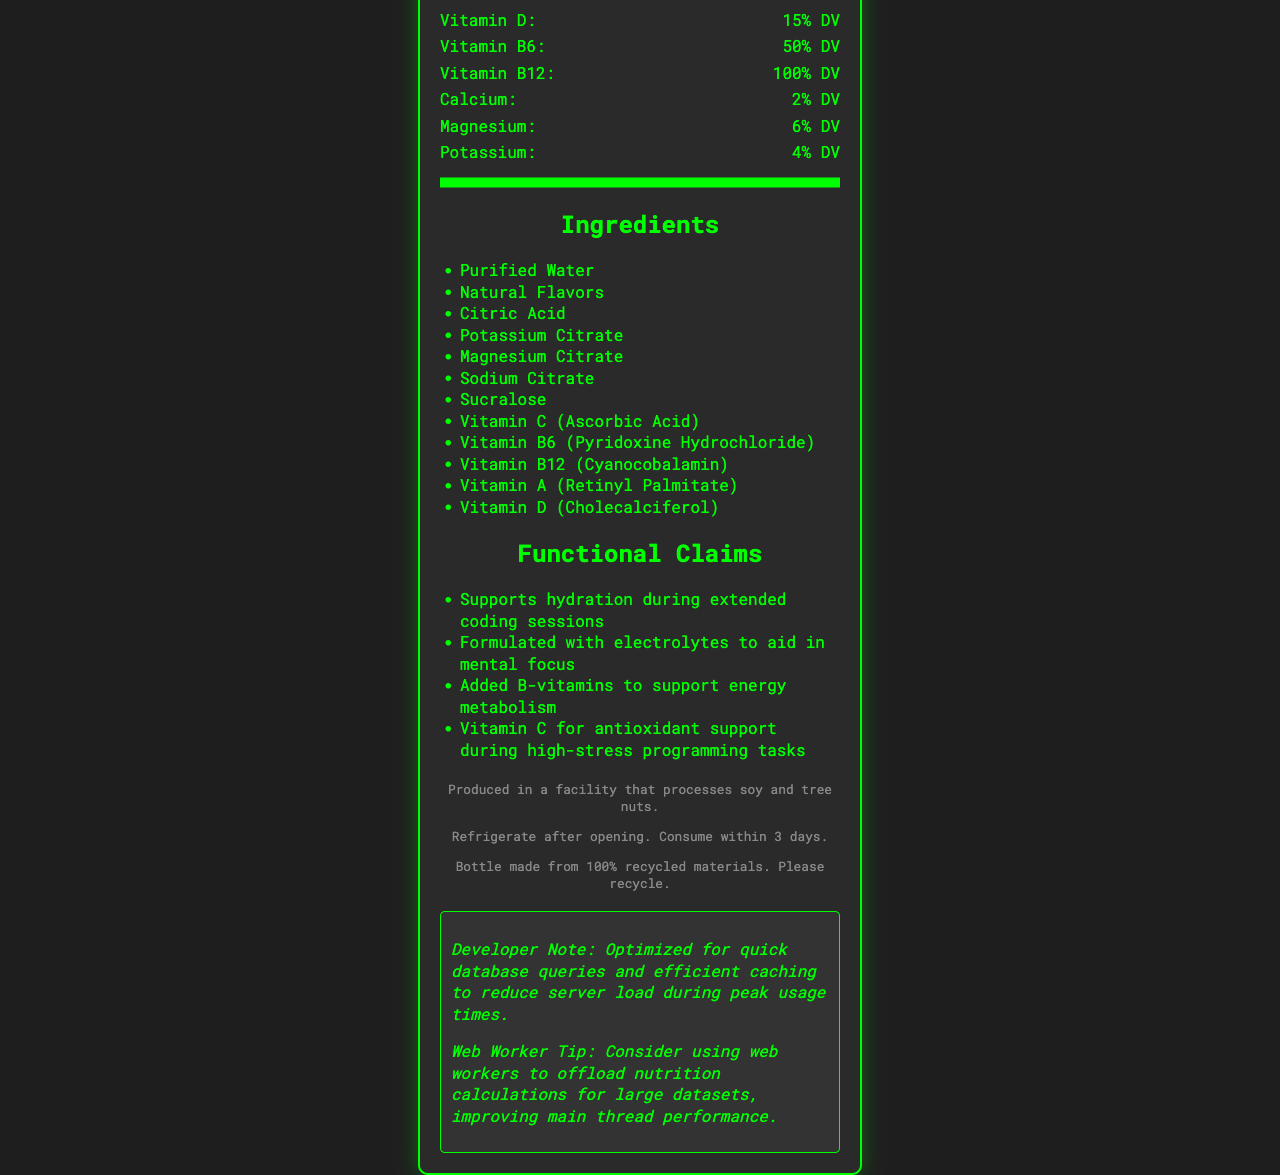what is the serving size? The serving size is explicitly stated in the document.
Answer: 500 mL (16.9 fl oz) how many calories are there per serving? The calories per serving are listed in the Nutrition Facts section.
Answer: 10 how much sodium does one serving contain? The amount of sodium per serving is provided in the Nutrition Facts.
Answer: 120mg what percentage of daily value for Vitamin C does this product provide? The daily value percentage for Vitamin C is given in the Nutrition Facts.
Answer: 100% DV how long should you consume the product after opening? The storage instructions state to consume within 3 days after opening.
Answer: Within 3 days what are the first three ingredients listed for this beverage? The first three ingredients are listed in the Ingredients section.
Answer: Purified Water, Natural Flavors, Citric Acid what is the main target for this product based on the functional claims? A. Athletes B. Developers C. Children D. Elderly The functional claims mention support for hydration during extended coding sessions and mental focus, which specifically target developers.
Answer: B. Developers how many vitamins listed provide more than 50% DV? A. 4 B. 2 C. 3 D. 5 Vitamins C (100% DV), B6 (50% DV), B12 (100% DV), and D (15% DV) are listed, but only Vitamins C, B6, and B12 provide more than 50% DV. Hence, the answer is 4.
Answer: A. 4 is the bottle made from recycled materials? It is stated that the bottle is made from 100% recycled materials.
Answer: Yes describe the main idea of the document. The document includes various sections that collectively describe the nutrition, functionality, and usage of the "CodeFuel Hydration+" beverage, highlighting its appeal to developers engaged in extended coding sessions.
Answer: The document provides the Nutrition Facts for "CodeFuel Hydration+", a vitamin-fortified water beverage designed to support hydration and concentration for developers during long coding sessions. It details the serving size, nutritional content, ingredients, functional claims, allergen information, storage instructions, and recycling details. does this product contain peanuts based on the allergen information? The allergen information states that it is produced in a facility that processes soy and tree nuts but does not specifically mention peanuts.
Answer: Cannot be determined what is the primary vitamin for antioxidant support during high-stress programming tasks? According to the functional claims, Vitamin C is mentioned for antioxidant support during high-stress programming tasks.
Answer: Vitamin C which electrolyte in the beverage is provided for hydration? The presence of magnesium citrate as an ingredient and the listing of magnesium in the Nutrition Facts suggest it is provided as an electrolyte for hydration.
Answer: Magnesium 